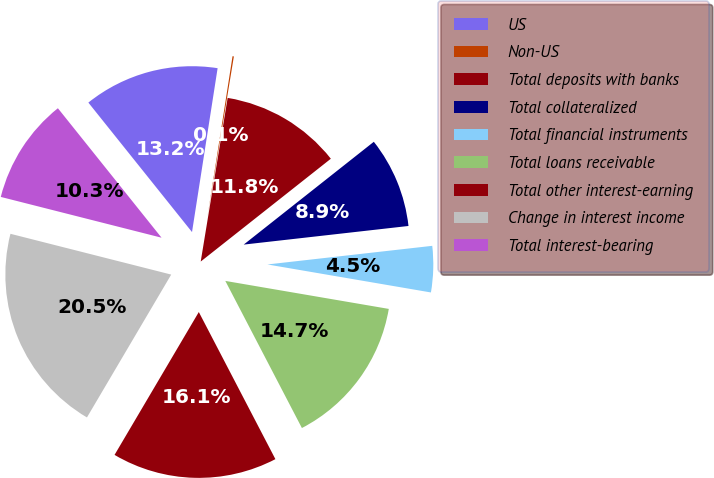<chart> <loc_0><loc_0><loc_500><loc_500><pie_chart><fcel>US<fcel>Non-US<fcel>Total deposits with banks<fcel>Total collateralized<fcel>Total financial instruments<fcel>Total loans receivable<fcel>Total other interest-earning<fcel>Change in interest income<fcel>Total interest-bearing<nl><fcel>13.21%<fcel>0.13%<fcel>11.76%<fcel>8.85%<fcel>4.49%<fcel>14.66%<fcel>16.12%<fcel>20.47%<fcel>10.3%<nl></chart> 